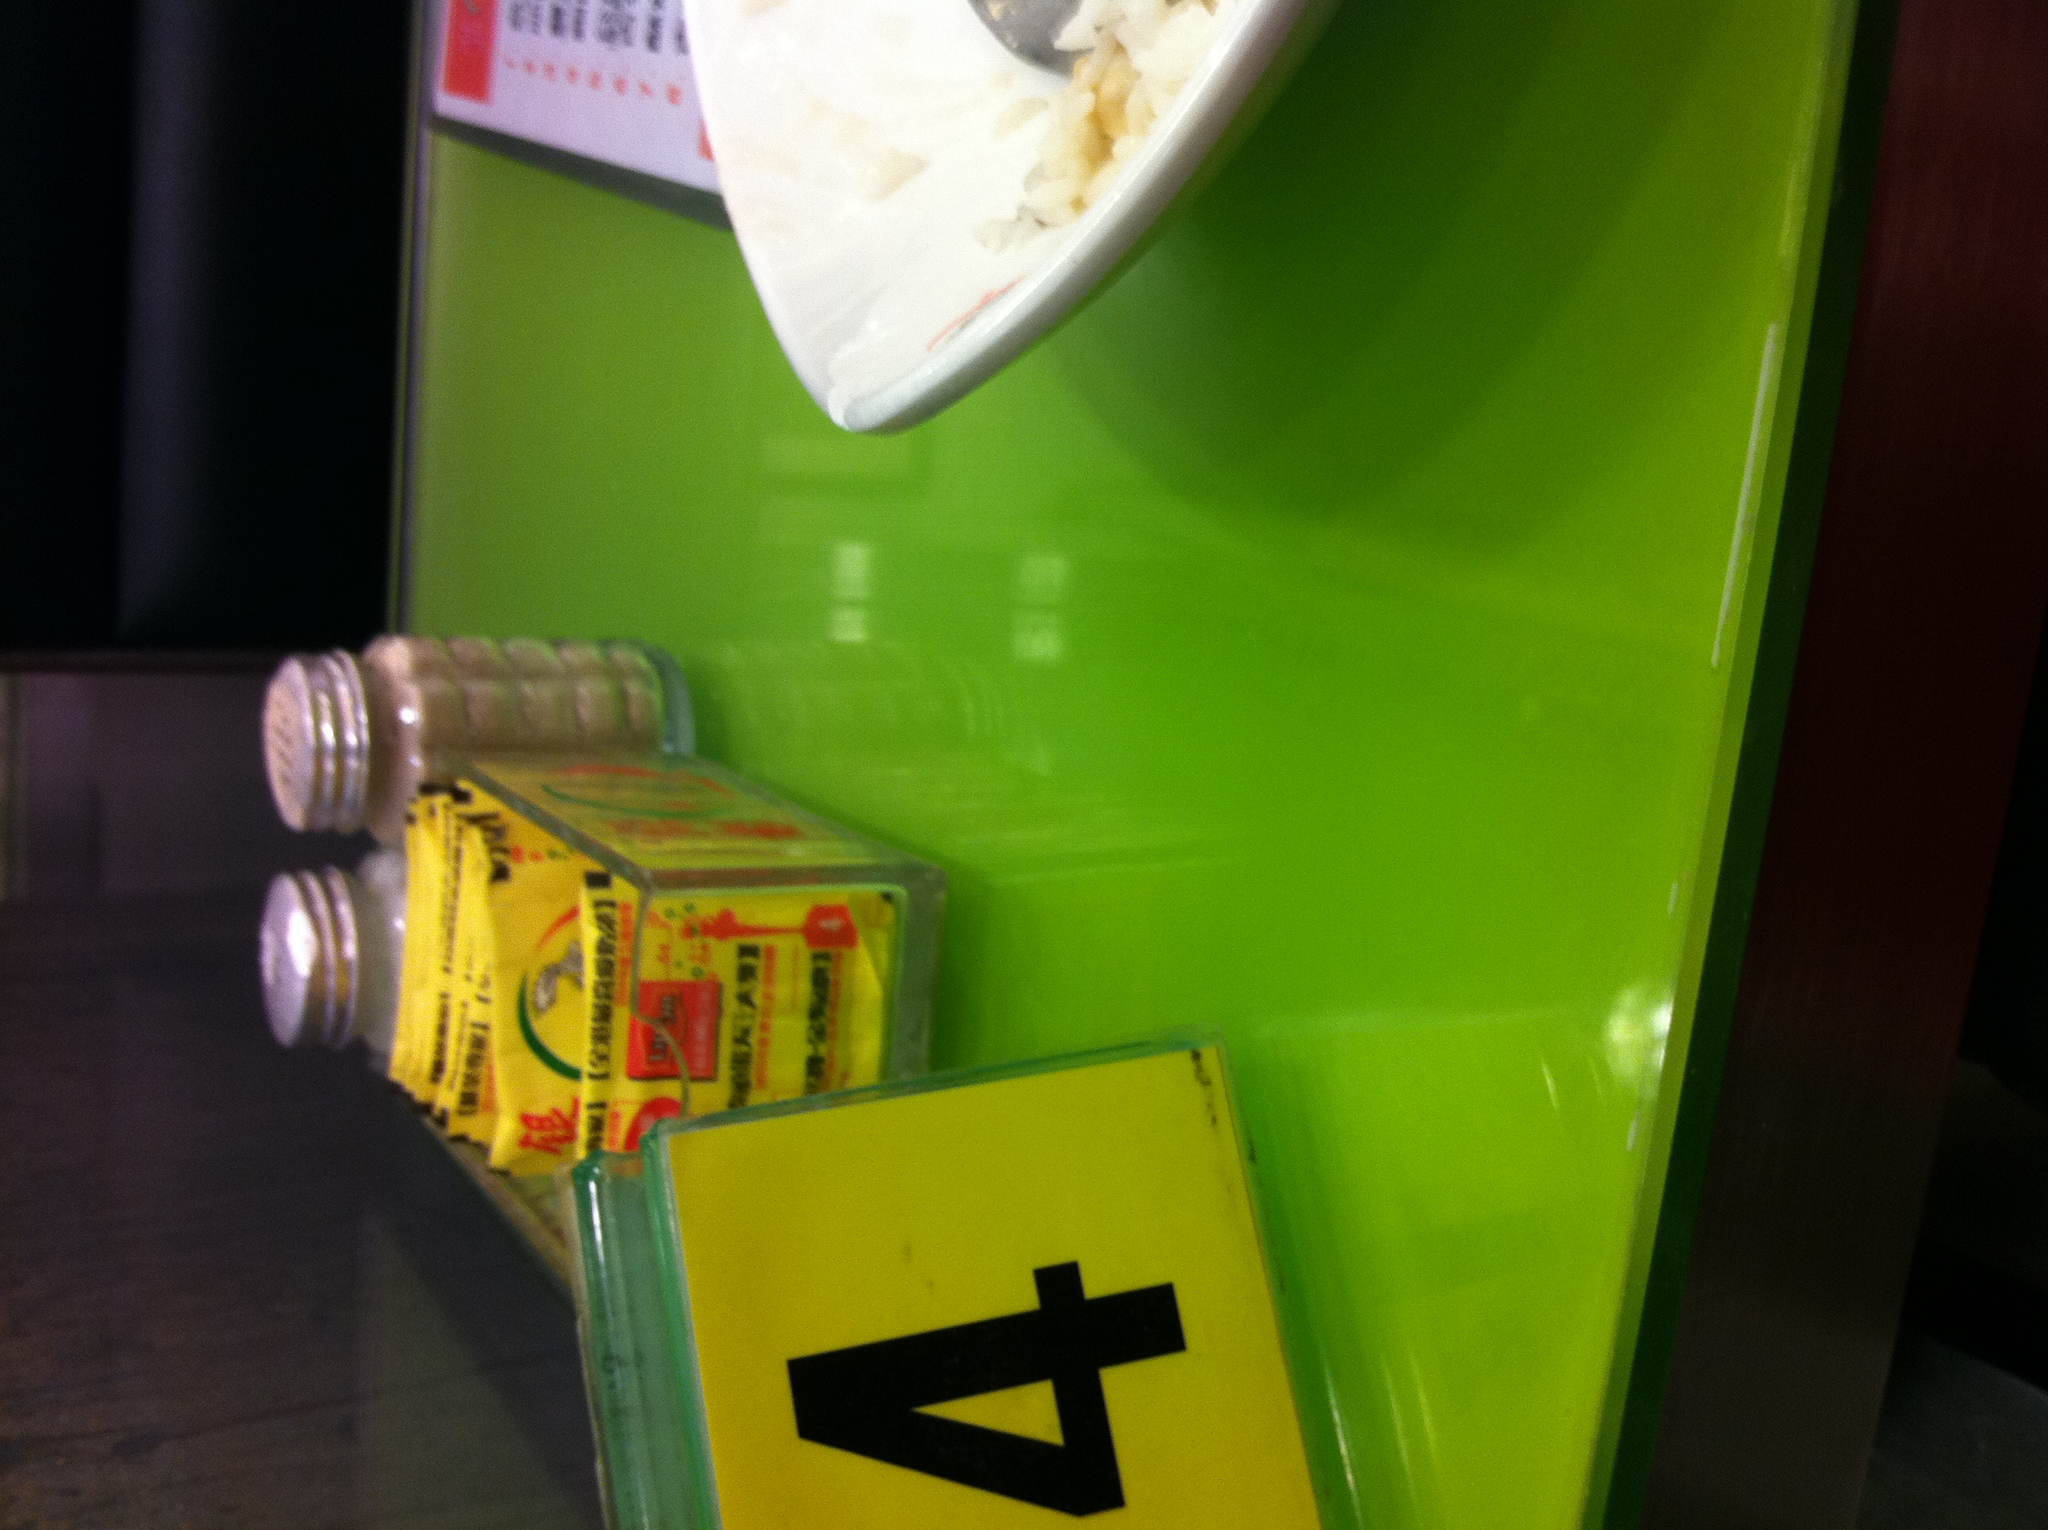Paint a picture of a day in the life of this table. As the day begins, the table gleams under the morning sun filtering through the restaurant windows. It feels the weight of placemats and cutlery being neatly arranged by the waitstaff. The aroma of freshly brewed coffee and sizzling breakfast dishes fills the air. Soon enough, it welcomes its first guests of the day—perhaps a pair of elderly friends sharing stories from their lives over a light breakfast. As the day progresses, the table hosts a variety of patrons: a bustling family at lunchtime with kids spilling juice and parents indulging in friendly conversations, and office workers grabbing a quick, solitary lunch while checking emails on their phones. By evening, the table is part of lively dinners, with groups of friends laughing aloud, raising toasts, and sharing platters of food that leave behind a mess of crumbs and spills. By the end of the day, the staff cleans up, and the table stands ready for another day of stories and experiences, a silent witness to the small but significant moments in the lives of many. 